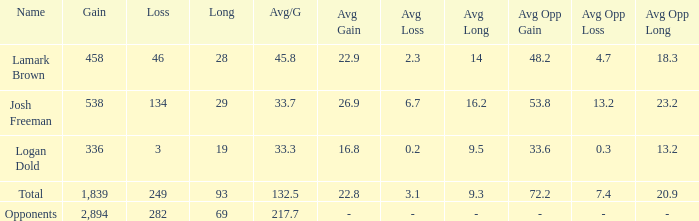With a long of 29 and an avg/g smaller than 33.7, what is the gain? 0.0. 